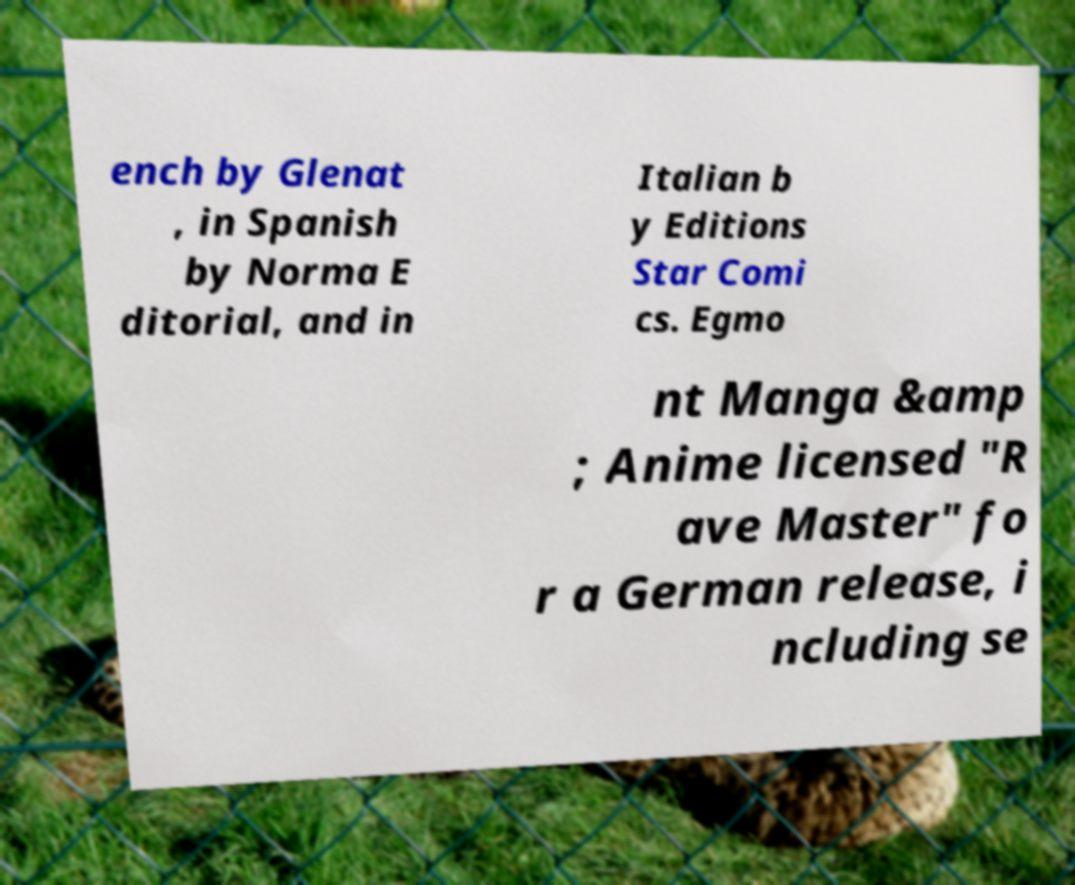Please read and relay the text visible in this image. What does it say? ench by Glenat , in Spanish by Norma E ditorial, and in Italian b y Editions Star Comi cs. Egmo nt Manga &amp ; Anime licensed "R ave Master" fo r a German release, i ncluding se 